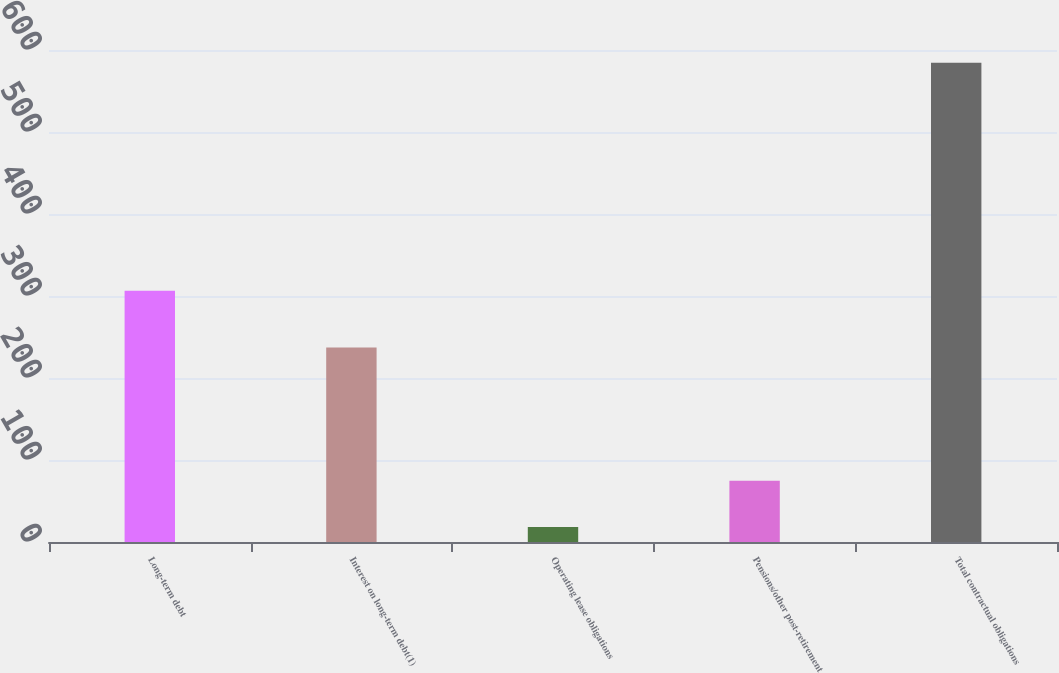<chart> <loc_0><loc_0><loc_500><loc_500><bar_chart><fcel>Long-term debt<fcel>Interest on long-term debt(1)<fcel>Operating lease obligations<fcel>Pensions/other post-retirement<fcel>Total contractual obligations<nl><fcel>306.5<fcel>237.2<fcel>18.2<fcel>74.82<fcel>584.4<nl></chart> 